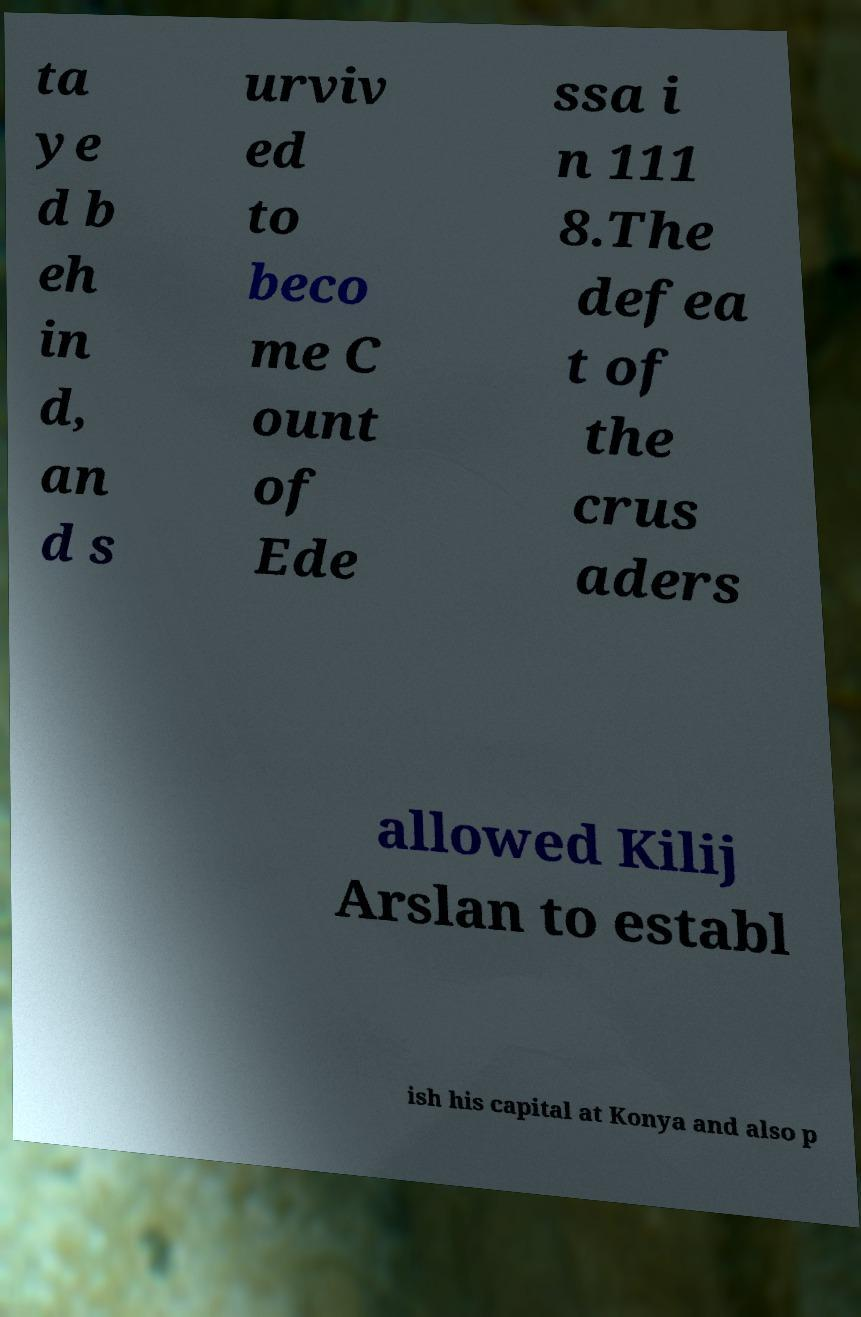I need the written content from this picture converted into text. Can you do that? ta ye d b eh in d, an d s urviv ed to beco me C ount of Ede ssa i n 111 8.The defea t of the crus aders allowed Kilij Arslan to establ ish his capital at Konya and also p 